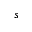Convert formula to latex. <formula><loc_0><loc_0><loc_500><loc_500>s</formula> 